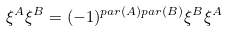Convert formula to latex. <formula><loc_0><loc_0><loc_500><loc_500>\xi ^ { A } \xi ^ { B } = ( - 1 ) ^ { p a r ( A ) p a r ( B ) } \xi ^ { B } \xi ^ { A }</formula> 